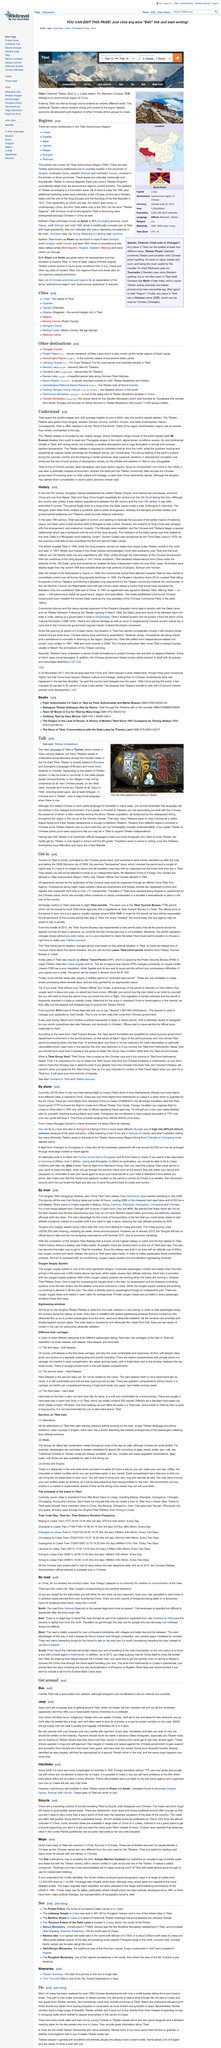List a handful of essential elements in this visual. The Tibetan Plateau is exposed to cold air originating from Yunnan. The Himalayan mountain range surrounds the Tibetan Plateau in the south. Tibet is often referred to as the 'Roof of the World' 